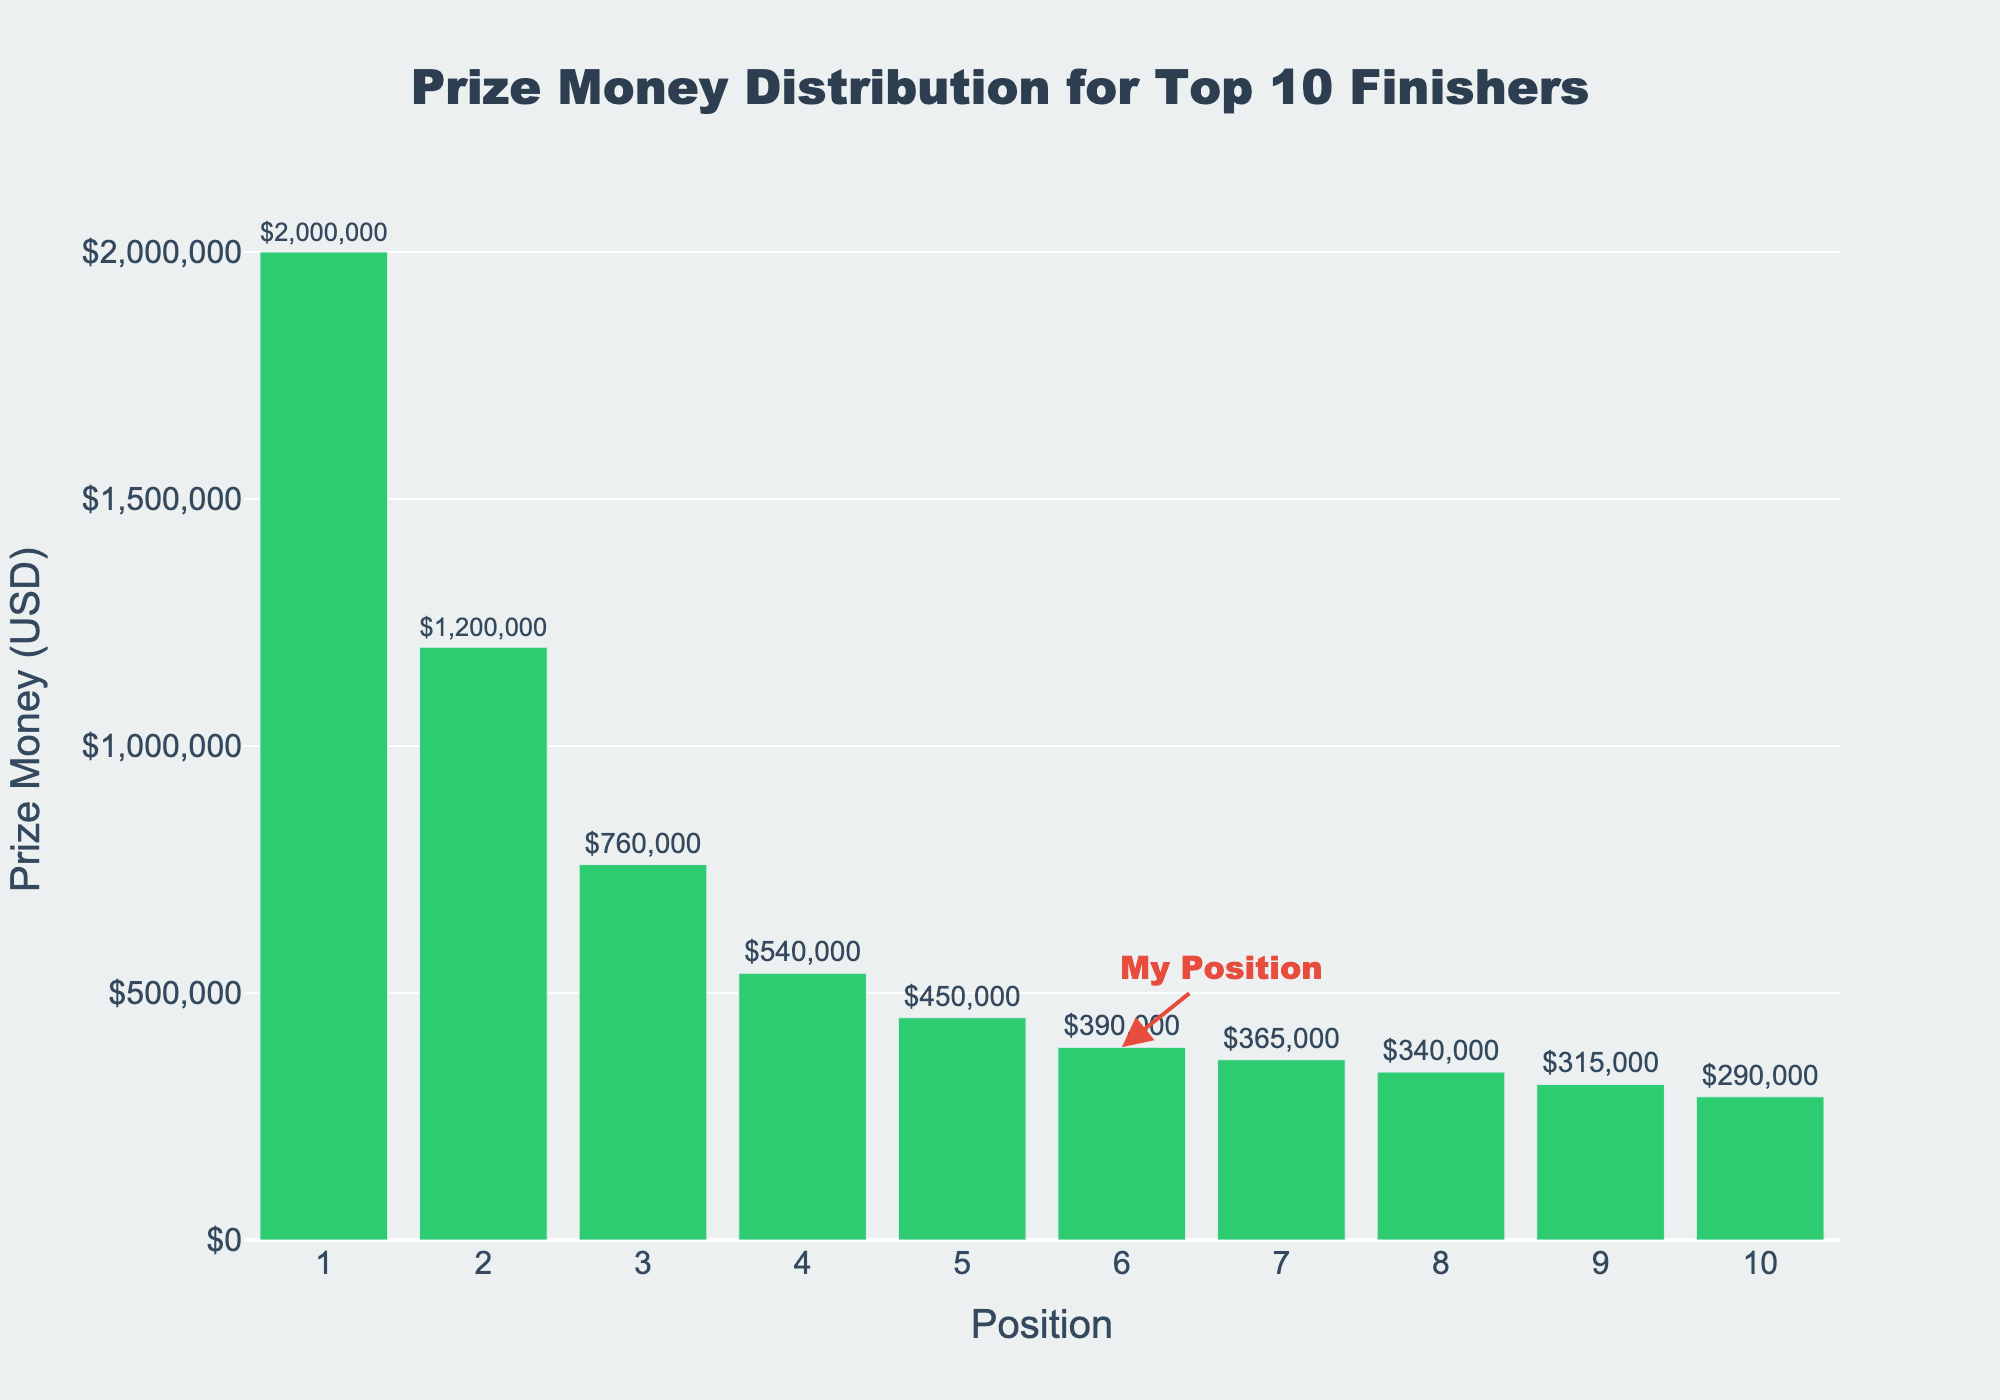What's the prize money for the 6th position? Look at the bar for the 6th position; it has a label indicating the prize money as $390,000.
Answer: $390,000 Which position has the highest prize money? Identify the tallest bar, which represents the 1st position with a prize money of $2,000,000.
Answer: 1st position How much more does the 4th position earn compared to the 10th position? The 4th position's bar represents $540,000 and the 10th position's bar represents $290,000. The difference is $540,000 - $290,000 = $250,000.
Answer: $250,000 What's the total prize money for the top 3 positions? The prize money for the top 3 positions are $2,000,000 for 1st, $1,200,000 for 2nd, and $760,000 for 3rd. Add them up: $2,000,000 + $1,200,000 + $760,000 = $3,960,000.
Answer: $3,960,000 What is the average prize money for positions 1 through 5? Calculate by summing the prize money for the first five positions ($2,000,000 + $1,200,000 + $760,000 + $540,000 + $450,000 = $4,950,000) and divide by 5: $4,950,000 / 5 = $990,000.
Answer: $990,000 Which position has the least prize money? Identify the shortest bar, which corresponds to the 10th position with a prize money of $290,000.
Answer: 10th position What is the combined prize money of the positions ranked lower than yours? Sum the prize money for positions 7 to 10: $365,000 (7th) + $340,000 (8th) + $315,000 (9th) + $290,000 (10th) = $1,310,000.
Answer: $1,310,000 What is the difference in prize money between the 2nd position and your position (6th)? The prize money for the 2nd position is $1,200,000 and for the 6th position is $390,000. The difference is $1,200,000 - $390,000 = $810,000.
Answer: $810,000 How many positions have prize money greater than $500,000? Count the bars with heights representing values higher than $500,000: 1st, 2nd, and 3rd positions.
Answer: 3 How much prize money did positions 8, 9, and 10 collectively earn? Sum the prize money for the 8th, 9th, and 10th positions: $340,000 + $315,000 + $290,000 = $945,000.
Answer: $945,000 